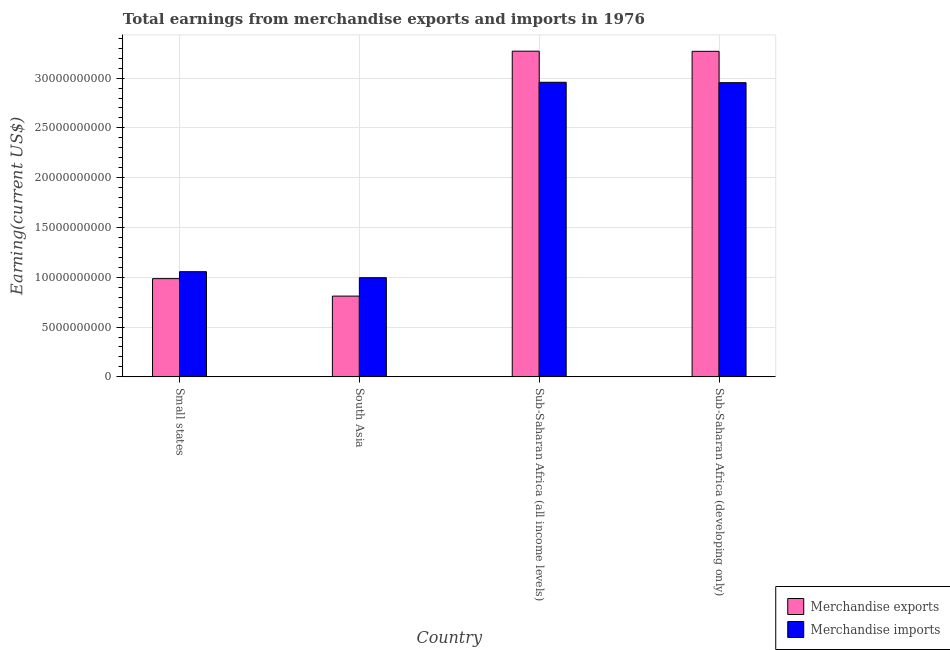How many different coloured bars are there?
Provide a short and direct response. 2. Are the number of bars on each tick of the X-axis equal?
Keep it short and to the point. Yes. What is the label of the 2nd group of bars from the left?
Your answer should be compact. South Asia. What is the earnings from merchandise exports in South Asia?
Your answer should be very brief. 8.11e+09. Across all countries, what is the maximum earnings from merchandise exports?
Provide a succinct answer. 3.27e+1. Across all countries, what is the minimum earnings from merchandise imports?
Make the answer very short. 9.96e+09. In which country was the earnings from merchandise imports maximum?
Your response must be concise. Sub-Saharan Africa (all income levels). In which country was the earnings from merchandise imports minimum?
Provide a short and direct response. South Asia. What is the total earnings from merchandise imports in the graph?
Your answer should be very brief. 7.96e+1. What is the difference between the earnings from merchandise imports in Small states and that in Sub-Saharan Africa (all income levels)?
Ensure brevity in your answer.  -1.90e+1. What is the difference between the earnings from merchandise imports in Sub-Saharan Africa (all income levels) and the earnings from merchandise exports in South Asia?
Make the answer very short. 2.15e+1. What is the average earnings from merchandise imports per country?
Provide a short and direct response. 1.99e+1. What is the difference between the earnings from merchandise exports and earnings from merchandise imports in Sub-Saharan Africa (developing only)?
Ensure brevity in your answer.  3.15e+09. In how many countries, is the earnings from merchandise exports greater than 12000000000 US$?
Your answer should be very brief. 2. What is the ratio of the earnings from merchandise imports in Sub-Saharan Africa (all income levels) to that in Sub-Saharan Africa (developing only)?
Ensure brevity in your answer.  1. What is the difference between the highest and the second highest earnings from merchandise imports?
Give a very brief answer. 4.13e+07. What is the difference between the highest and the lowest earnings from merchandise exports?
Your response must be concise. 2.46e+1. In how many countries, is the earnings from merchandise exports greater than the average earnings from merchandise exports taken over all countries?
Your response must be concise. 2. What does the 1st bar from the left in South Asia represents?
Provide a short and direct response. Merchandise exports. What does the 2nd bar from the right in Small states represents?
Your response must be concise. Merchandise exports. Are all the bars in the graph horizontal?
Make the answer very short. No. How many countries are there in the graph?
Your answer should be compact. 4. Does the graph contain any zero values?
Ensure brevity in your answer.  No. Does the graph contain grids?
Your answer should be very brief. Yes. What is the title of the graph?
Make the answer very short. Total earnings from merchandise exports and imports in 1976. Does "Secondary" appear as one of the legend labels in the graph?
Keep it short and to the point. No. What is the label or title of the Y-axis?
Make the answer very short. Earning(current US$). What is the Earning(current US$) of Merchandise exports in Small states?
Provide a short and direct response. 9.86e+09. What is the Earning(current US$) in Merchandise imports in Small states?
Provide a succinct answer. 1.06e+1. What is the Earning(current US$) in Merchandise exports in South Asia?
Your response must be concise. 8.11e+09. What is the Earning(current US$) in Merchandise imports in South Asia?
Keep it short and to the point. 9.96e+09. What is the Earning(current US$) in Merchandise exports in Sub-Saharan Africa (all income levels)?
Your answer should be very brief. 3.27e+1. What is the Earning(current US$) in Merchandise imports in Sub-Saharan Africa (all income levels)?
Ensure brevity in your answer.  2.96e+1. What is the Earning(current US$) in Merchandise exports in Sub-Saharan Africa (developing only)?
Offer a very short reply. 3.27e+1. What is the Earning(current US$) of Merchandise imports in Sub-Saharan Africa (developing only)?
Offer a very short reply. 2.95e+1. Across all countries, what is the maximum Earning(current US$) of Merchandise exports?
Ensure brevity in your answer.  3.27e+1. Across all countries, what is the maximum Earning(current US$) of Merchandise imports?
Provide a succinct answer. 2.96e+1. Across all countries, what is the minimum Earning(current US$) of Merchandise exports?
Your answer should be very brief. 8.11e+09. Across all countries, what is the minimum Earning(current US$) in Merchandise imports?
Keep it short and to the point. 9.96e+09. What is the total Earning(current US$) of Merchandise exports in the graph?
Your answer should be compact. 8.34e+1. What is the total Earning(current US$) in Merchandise imports in the graph?
Provide a succinct answer. 7.96e+1. What is the difference between the Earning(current US$) in Merchandise exports in Small states and that in South Asia?
Provide a short and direct response. 1.75e+09. What is the difference between the Earning(current US$) of Merchandise imports in Small states and that in South Asia?
Your answer should be very brief. 6.04e+08. What is the difference between the Earning(current US$) in Merchandise exports in Small states and that in Sub-Saharan Africa (all income levels)?
Your response must be concise. -2.28e+1. What is the difference between the Earning(current US$) of Merchandise imports in Small states and that in Sub-Saharan Africa (all income levels)?
Keep it short and to the point. -1.90e+1. What is the difference between the Earning(current US$) in Merchandise exports in Small states and that in Sub-Saharan Africa (developing only)?
Your response must be concise. -2.28e+1. What is the difference between the Earning(current US$) in Merchandise imports in Small states and that in Sub-Saharan Africa (developing only)?
Keep it short and to the point. -1.90e+1. What is the difference between the Earning(current US$) of Merchandise exports in South Asia and that in Sub-Saharan Africa (all income levels)?
Make the answer very short. -2.46e+1. What is the difference between the Earning(current US$) of Merchandise imports in South Asia and that in Sub-Saharan Africa (all income levels)?
Give a very brief answer. -1.96e+1. What is the difference between the Earning(current US$) in Merchandise exports in South Asia and that in Sub-Saharan Africa (developing only)?
Provide a succinct answer. -2.46e+1. What is the difference between the Earning(current US$) of Merchandise imports in South Asia and that in Sub-Saharan Africa (developing only)?
Give a very brief answer. -1.96e+1. What is the difference between the Earning(current US$) in Merchandise exports in Sub-Saharan Africa (all income levels) and that in Sub-Saharan Africa (developing only)?
Keep it short and to the point. 1.68e+07. What is the difference between the Earning(current US$) in Merchandise imports in Sub-Saharan Africa (all income levels) and that in Sub-Saharan Africa (developing only)?
Give a very brief answer. 4.13e+07. What is the difference between the Earning(current US$) in Merchandise exports in Small states and the Earning(current US$) in Merchandise imports in South Asia?
Your answer should be compact. -9.45e+07. What is the difference between the Earning(current US$) in Merchandise exports in Small states and the Earning(current US$) in Merchandise imports in Sub-Saharan Africa (all income levels)?
Your response must be concise. -1.97e+1. What is the difference between the Earning(current US$) of Merchandise exports in Small states and the Earning(current US$) of Merchandise imports in Sub-Saharan Africa (developing only)?
Provide a short and direct response. -1.97e+1. What is the difference between the Earning(current US$) in Merchandise exports in South Asia and the Earning(current US$) in Merchandise imports in Sub-Saharan Africa (all income levels)?
Your answer should be very brief. -2.15e+1. What is the difference between the Earning(current US$) in Merchandise exports in South Asia and the Earning(current US$) in Merchandise imports in Sub-Saharan Africa (developing only)?
Make the answer very short. -2.14e+1. What is the difference between the Earning(current US$) in Merchandise exports in Sub-Saharan Africa (all income levels) and the Earning(current US$) in Merchandise imports in Sub-Saharan Africa (developing only)?
Give a very brief answer. 3.17e+09. What is the average Earning(current US$) of Merchandise exports per country?
Make the answer very short. 2.08e+1. What is the average Earning(current US$) of Merchandise imports per country?
Make the answer very short. 1.99e+1. What is the difference between the Earning(current US$) in Merchandise exports and Earning(current US$) in Merchandise imports in Small states?
Offer a very short reply. -6.98e+08. What is the difference between the Earning(current US$) in Merchandise exports and Earning(current US$) in Merchandise imports in South Asia?
Ensure brevity in your answer.  -1.85e+09. What is the difference between the Earning(current US$) of Merchandise exports and Earning(current US$) of Merchandise imports in Sub-Saharan Africa (all income levels)?
Provide a short and direct response. 3.12e+09. What is the difference between the Earning(current US$) in Merchandise exports and Earning(current US$) in Merchandise imports in Sub-Saharan Africa (developing only)?
Ensure brevity in your answer.  3.15e+09. What is the ratio of the Earning(current US$) of Merchandise exports in Small states to that in South Asia?
Your answer should be very brief. 1.22. What is the ratio of the Earning(current US$) of Merchandise imports in Small states to that in South Asia?
Your response must be concise. 1.06. What is the ratio of the Earning(current US$) in Merchandise exports in Small states to that in Sub-Saharan Africa (all income levels)?
Your response must be concise. 0.3. What is the ratio of the Earning(current US$) in Merchandise imports in Small states to that in Sub-Saharan Africa (all income levels)?
Your answer should be very brief. 0.36. What is the ratio of the Earning(current US$) of Merchandise exports in Small states to that in Sub-Saharan Africa (developing only)?
Give a very brief answer. 0.3. What is the ratio of the Earning(current US$) in Merchandise imports in Small states to that in Sub-Saharan Africa (developing only)?
Provide a succinct answer. 0.36. What is the ratio of the Earning(current US$) in Merchandise exports in South Asia to that in Sub-Saharan Africa (all income levels)?
Your answer should be very brief. 0.25. What is the ratio of the Earning(current US$) of Merchandise imports in South Asia to that in Sub-Saharan Africa (all income levels)?
Provide a succinct answer. 0.34. What is the ratio of the Earning(current US$) of Merchandise exports in South Asia to that in Sub-Saharan Africa (developing only)?
Your answer should be compact. 0.25. What is the ratio of the Earning(current US$) in Merchandise imports in South Asia to that in Sub-Saharan Africa (developing only)?
Your answer should be very brief. 0.34. What is the ratio of the Earning(current US$) in Merchandise exports in Sub-Saharan Africa (all income levels) to that in Sub-Saharan Africa (developing only)?
Keep it short and to the point. 1. What is the difference between the highest and the second highest Earning(current US$) of Merchandise exports?
Your answer should be compact. 1.68e+07. What is the difference between the highest and the second highest Earning(current US$) in Merchandise imports?
Offer a terse response. 4.13e+07. What is the difference between the highest and the lowest Earning(current US$) in Merchandise exports?
Your response must be concise. 2.46e+1. What is the difference between the highest and the lowest Earning(current US$) in Merchandise imports?
Your response must be concise. 1.96e+1. 